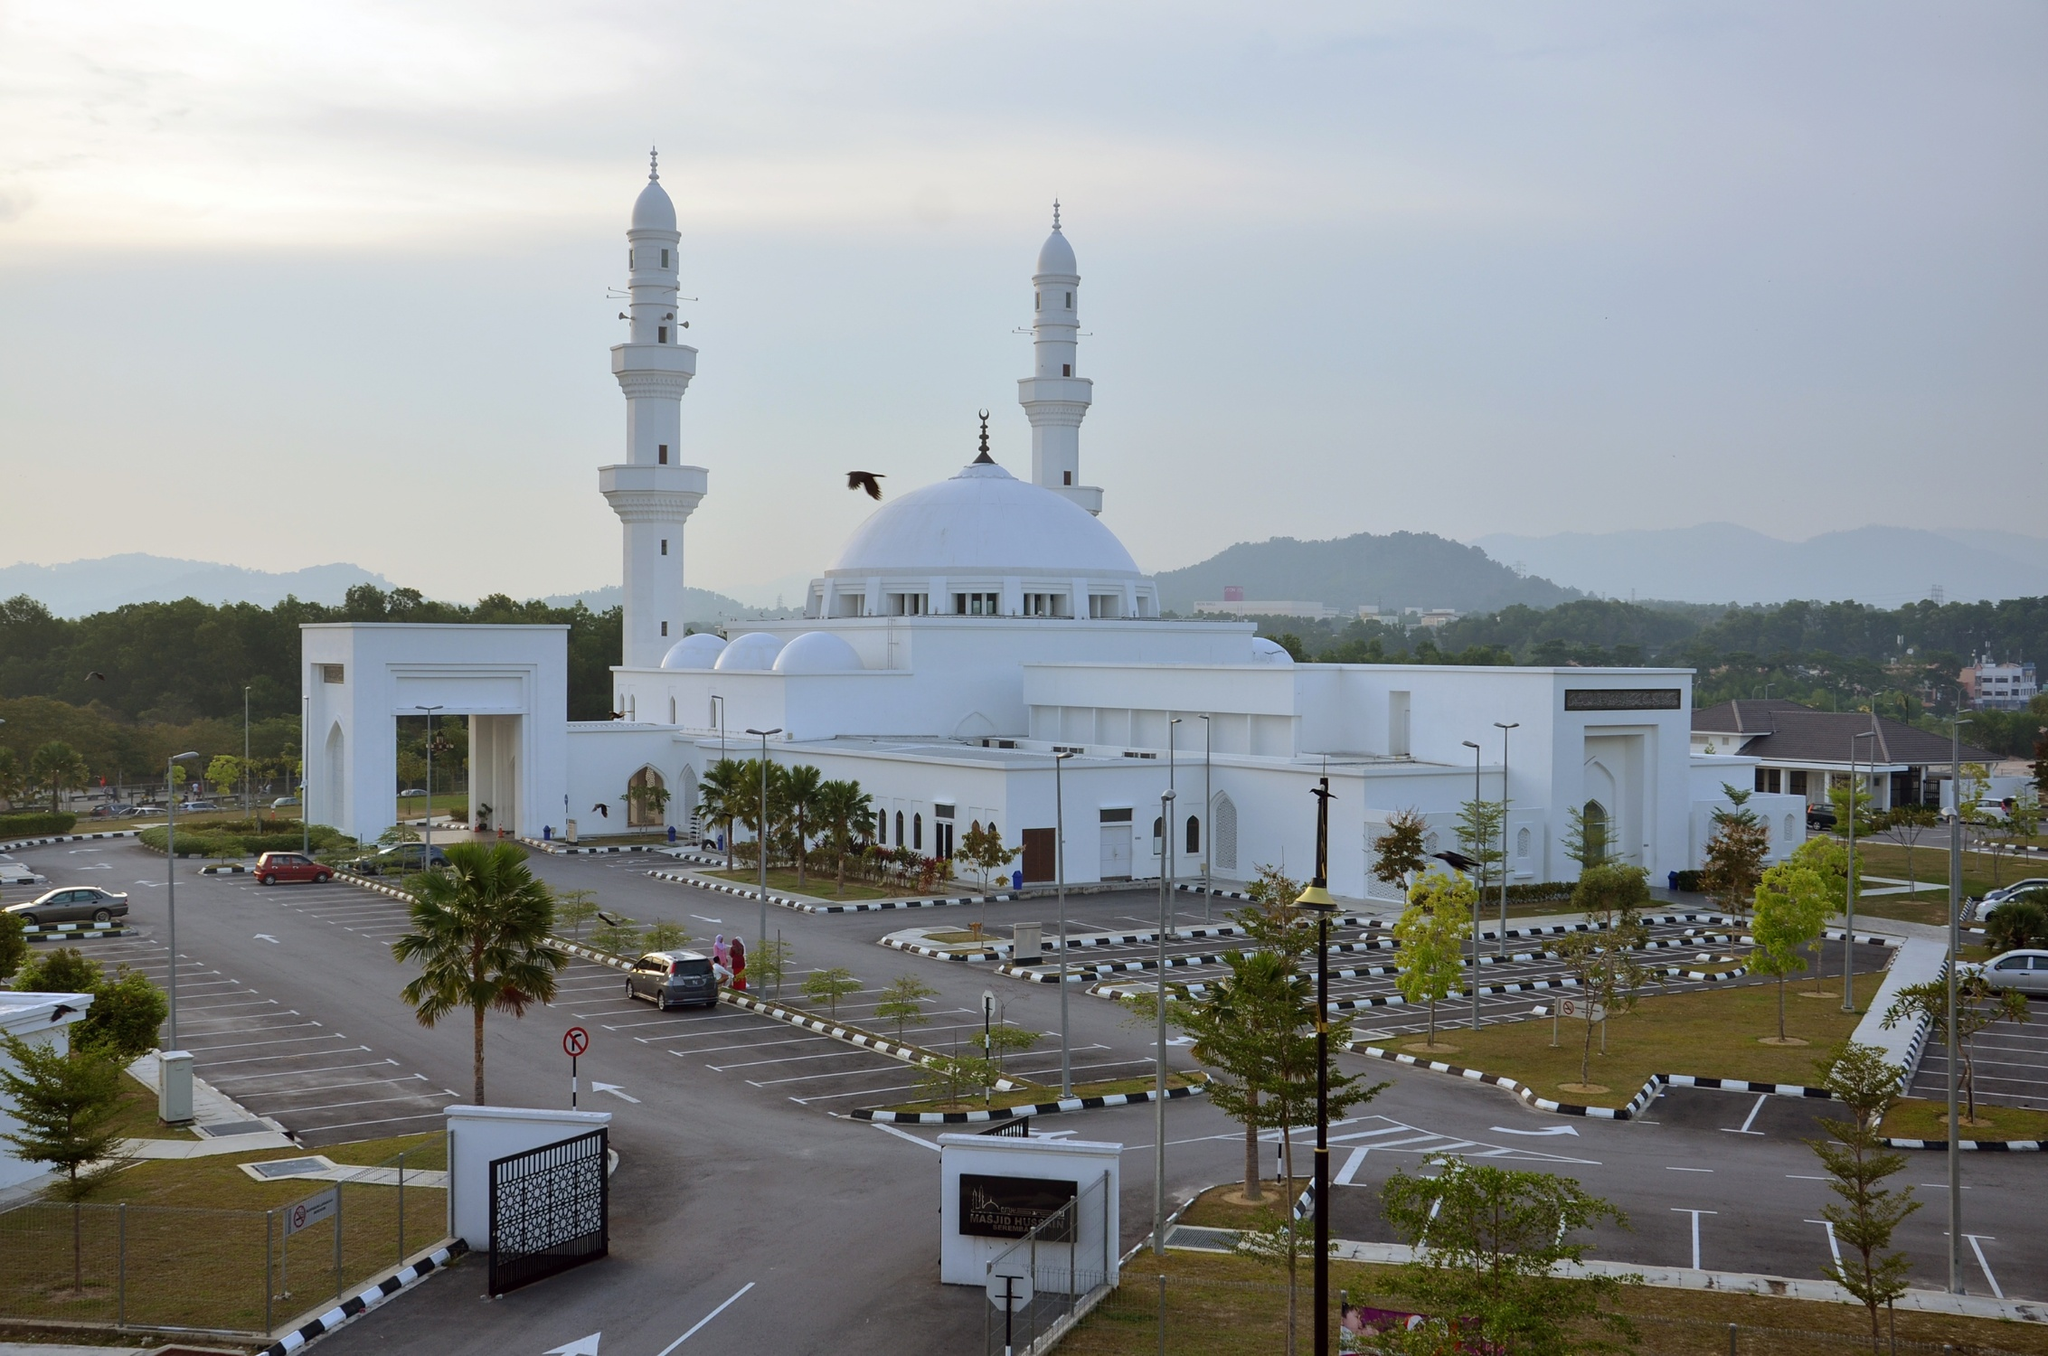Can you describe the environment surrounding the mosque? The Tengku Ampuan Jemaah Mosque is situated in a tranquil environment in Bukit Jelutong, Malaysia. Surrounding the splendid mosque is a vast parking area interspersed with orderly rows of trees and manicured lawns, reflecting careful urban planning and maintenance. The vicinity is relatively calm and spacious, with distant green hills providing a serene backdrop against the sky. Nestled within a developed neighborhood, the mosque is easily accessible, and one can notice the harmonious blend of natural greenery with the built environment. 